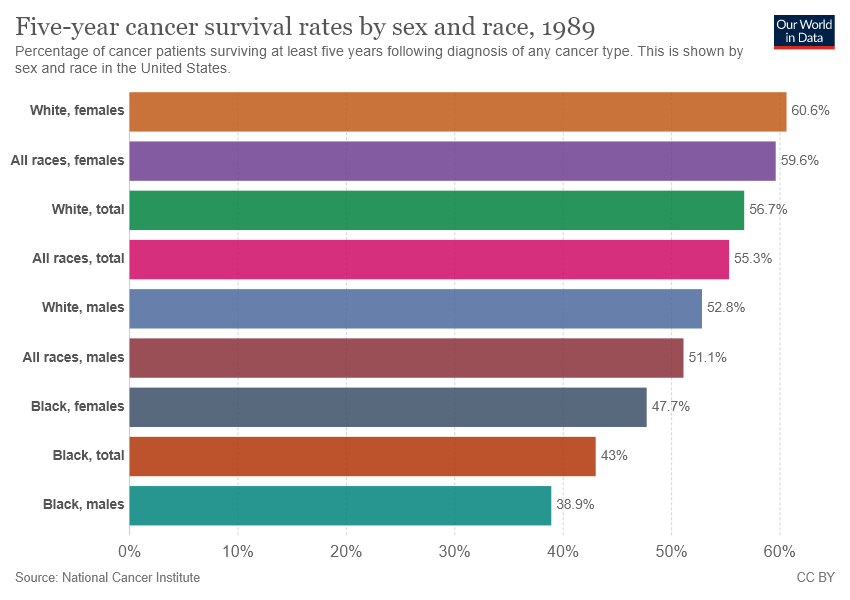Draw attention to some important aspects in this diagram. The green bar represents the category of white. The difference between the second highest value and the median value of all bars is 0.068. 